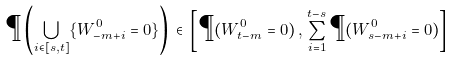Convert formula to latex. <formula><loc_0><loc_0><loc_500><loc_500>\P \left ( \bigcup _ { i \in [ s , t ] } \{ W ^ { 0 } _ { - m + i } = 0 \} \right ) \, \in \, \left [ \P ( W ^ { 0 } _ { t - m } = 0 ) \, , \, \sum _ { i = 1 } ^ { t - s } \P ( W ^ { 0 } _ { s - m + i } = 0 ) \right ]</formula> 